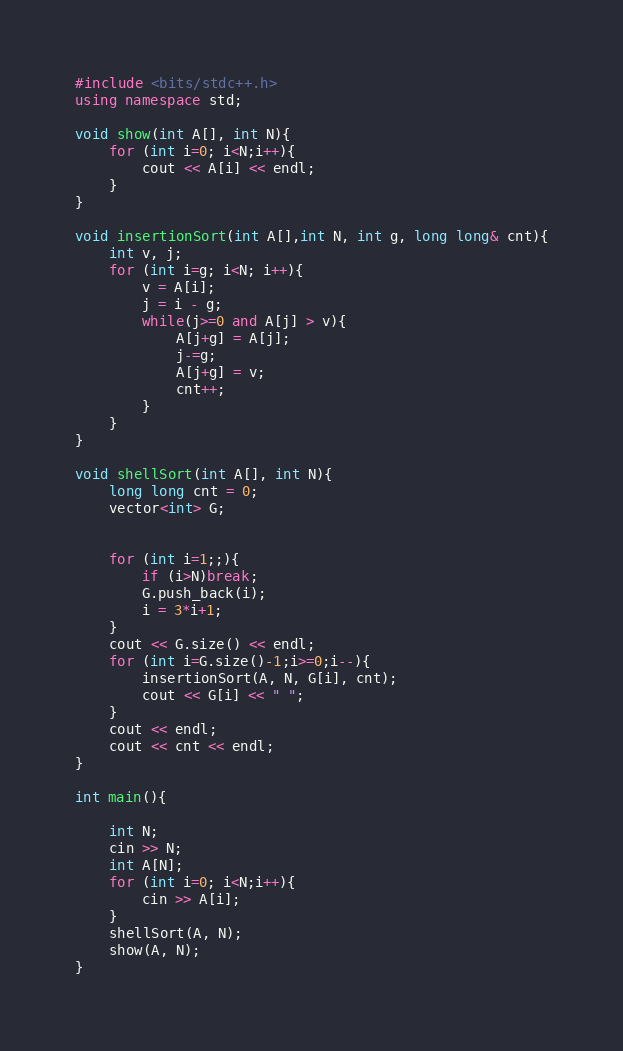Convert code to text. <code><loc_0><loc_0><loc_500><loc_500><_C++_>#include <bits/stdc++.h>
using namespace std;

void show(int A[], int N){
    for (int i=0; i<N;i++){
        cout << A[i] << endl;
    }
}

void insertionSort(int A[],int N, int g, long long& cnt){
    int v, j;
    for (int i=g; i<N; i++){
        v = A[i];
        j = i - g;
        while(j>=0 and A[j] > v){
            A[j+g] = A[j];
            j-=g;
            A[j+g] = v;
            cnt++;
        }
    }
}

void shellSort(int A[], int N){
    long long cnt = 0;
    vector<int> G;

    
    for (int i=1;;){
        if (i>N)break;
        G.push_back(i);
        i = 3*i+1;
    }
    cout << G.size() << endl;
    for (int i=G.size()-1;i>=0;i--){
        insertionSort(A, N, G[i], cnt);
        cout << G[i] << " ";
    }
    cout << endl;
    cout << cnt << endl;
}

int main(){

    int N;
    cin >> N;
    int A[N];
    for (int i=0; i<N;i++){
        cin >> A[i];
    }
    shellSort(A, N);
    show(A, N);
}</code> 